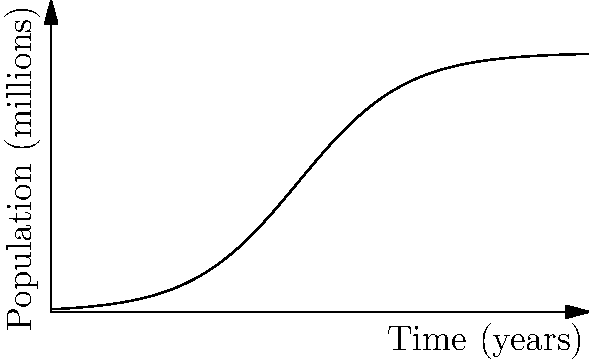Consider the logistic growth function $P(t) = \frac{100}{1+99e^{-0.2t}}$, which models a population in millions over time t in years. At what point in time is the rate of population growth the highest? To find the point of maximum growth rate, we need to follow these steps:

1) The rate of change is given by the derivative of P(t). Let's call this P'(t).

2) The logistic growth function has its maximum rate of change at the inflection point, which occurs at half the carrying capacity.

3) The carrying capacity (K) in this model is 100 million.

4) Half of the carrying capacity is 50 million.

5) To find when P(t) = 50, we solve the equation:

   $50 = \frac{100}{1+99e^{-0.2t}}$

6) Simplifying:
   $1+99e^{-0.2t} = 2$
   $99e^{-0.2t} = 1$
   $e^{-0.2t} = \frac{1}{99}$

7) Taking the natural log of both sides:
   $-0.2t = \ln(\frac{1}{99})$
   $t = -\frac{1}{0.2}\ln(\frac{1}{99}) = \frac{\ln(99)}{0.2} \approx 23.03$

Therefore, the rate of population growth is highest at approximately 23.03 years.
Answer: 23.03 years 